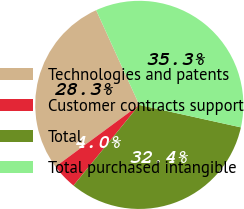Convert chart. <chart><loc_0><loc_0><loc_500><loc_500><pie_chart><fcel>Technologies and patents<fcel>Customer contracts support<fcel>Total<fcel>Total purchased intangible<nl><fcel>28.31%<fcel>4.0%<fcel>32.42%<fcel>35.26%<nl></chart> 